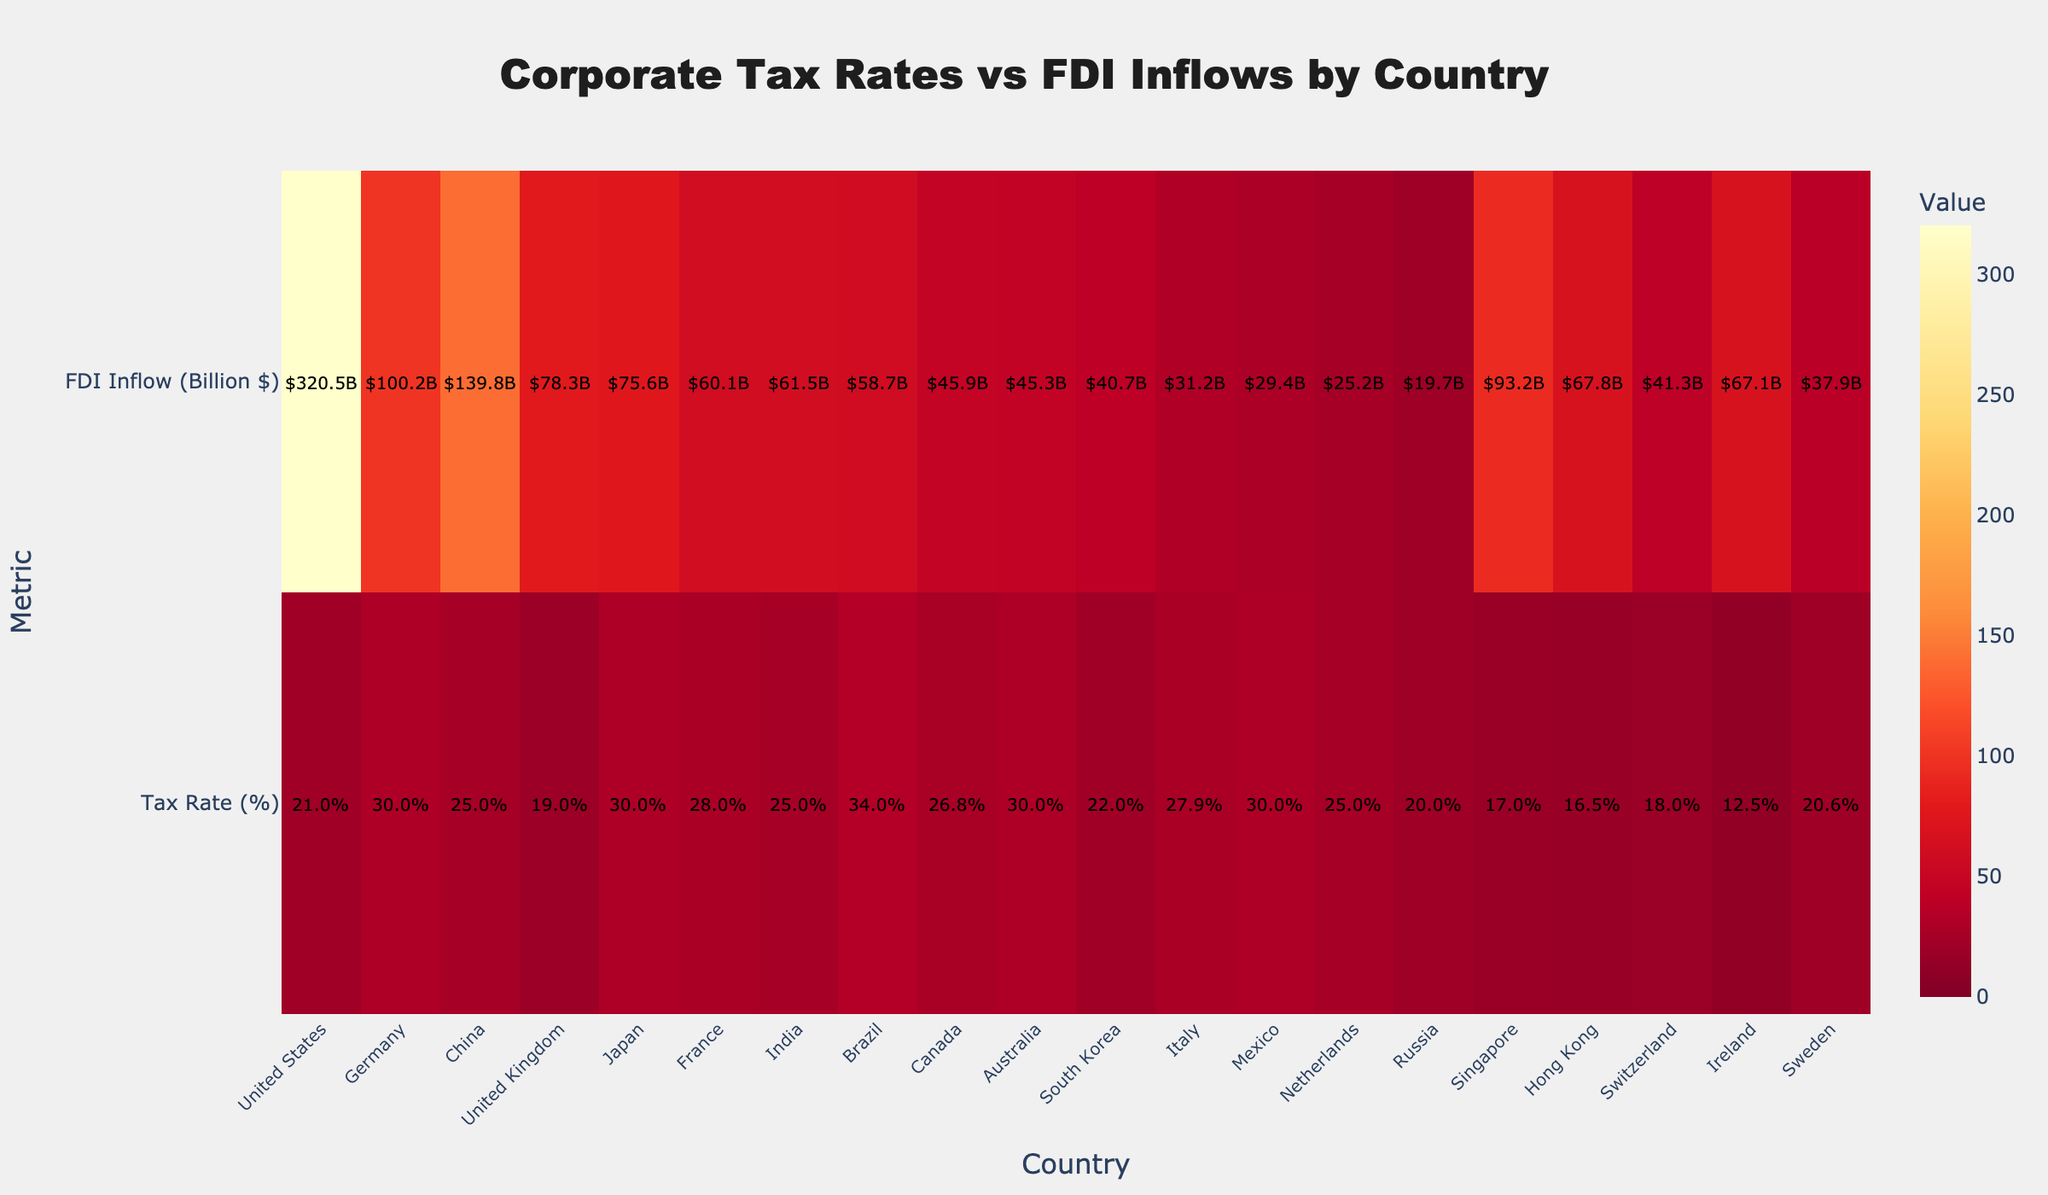What is the title of the heatmap? The title of the heatmap can be seen at the top of the figure which reads "Corporate Tax Rates vs FDI Inflows by Country".
Answer: Corporate Tax Rates vs FDI Inflows by Country Which country has the lowest corporate tax rate and what is it? By looking at the annotations for each country, the country with the lowest corporate tax rate is Ireland with a tax rate of 12.5%.
Answer: Ireland, 12.5% How does the FDI inflow for the United States compare to that of Germany? From the FDI Inflow annotations, the United States has an FDI inflow of 320.5 billion dollars, while Germany has an FDI inflow of 100.2 billion dollars. Therefore, the United States has a significantly higher FDI inflow compared to Germany.
Answer: United States has higher FDI inflow What is the combined FDI inflow of Japan and Brazil? Japan has an FDI inflow of 75.6 billion dollars, and Brazil has an FDI inflow of 58.7 billion dollars. Adding these two, 75.6 + 58.7 = 134.3 billion dollars.
Answer: 134.3 billion dollars Which countries have a corporate tax rate higher than 30%? The columns with tax rates annotated show that Germany, Japan, Brazil, and Mexico each have a tax rate higher than 30%.
Answer: Germany, Japan, Brazil, Mexico What is the average corporate tax rate across all countries listed? Sum all the tax rates and divide by the number of countries. Sum = 21+30+25+19+30+28+25+34+26.8+30+22+27.9+30+25+20+17+16.5+18+12.5+20.6 = 478.3. Number of countries = 20. Average = 478.3 / 20 = 23.915%
Answer: 23.915% How does Switzerland’s FDI inflow compare to that of South Korea? From the annotations, Switzerland has an FDI inflow of 41.3 billion dollars, while South Korea has an inflow of 40.7 billion dollars. Switzerland's FDI inflow is slightly higher.
Answer: Switzerland's is higher Which country has the highest FDI inflow and what is the value? The highest value for FDI inflow seen in the annotations on the heatmap is for the United States with 320.5 billion dollars.
Answer: United States, 320.5 billion dollars Is there a visible trend between lower tax rates and higher FDI inflows? Observing the heatmap, some countries with lower tax rates such as Singapore, Hong Kong, and Ireland have high FDI inflows, but there are exceptions like the United States which has a higher tax rate and the highest FDI inflow. So, the trend is not strongly conclusive from this visualization alone.
Answer: No strong trend 